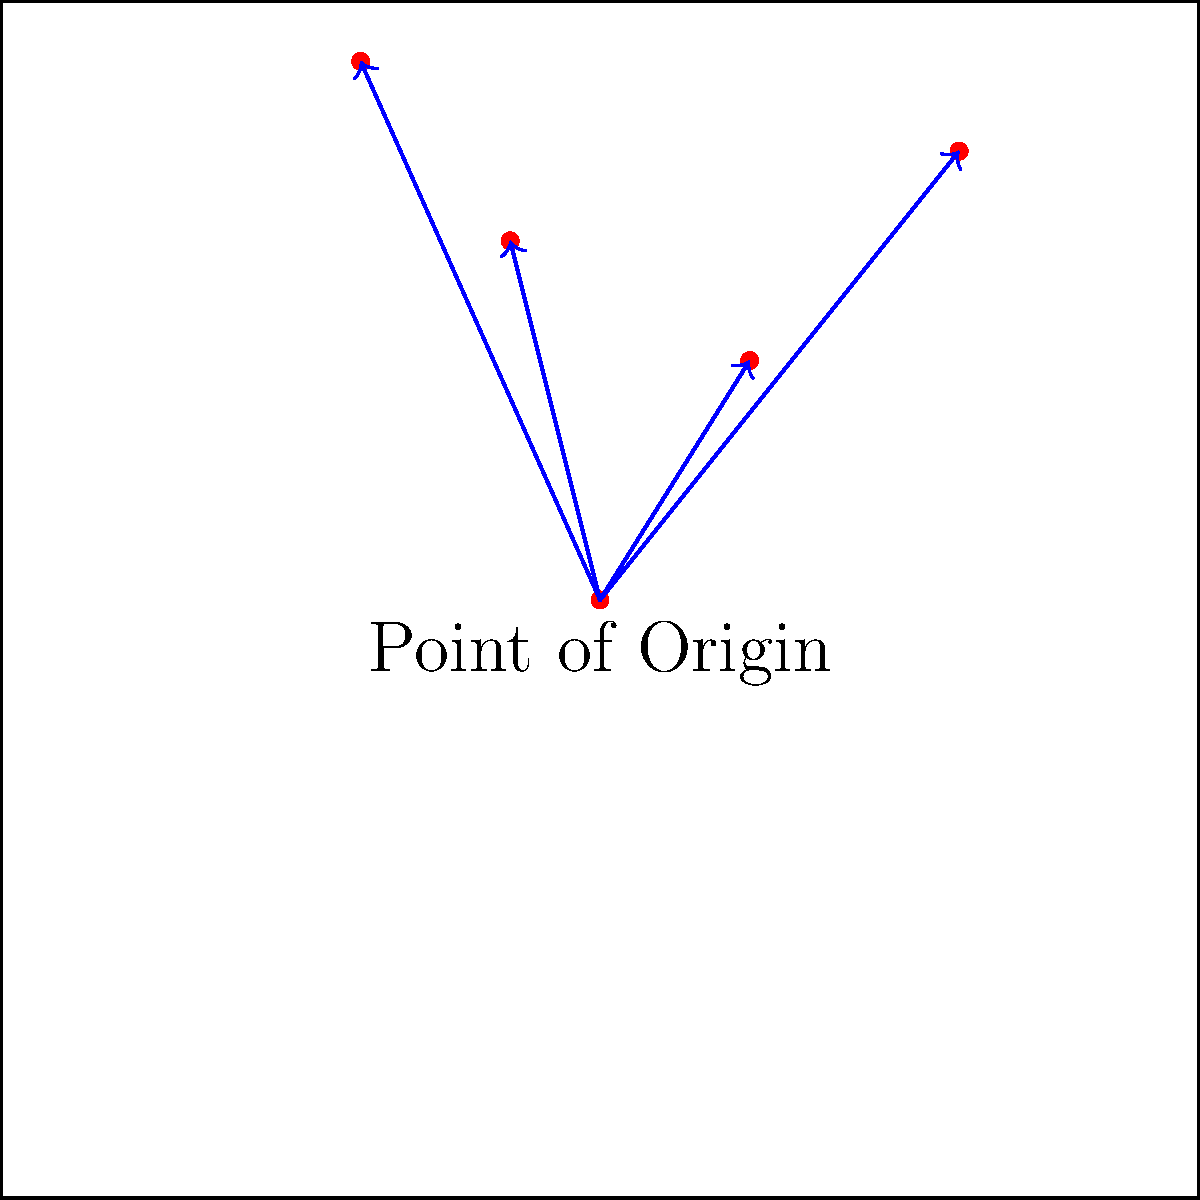Based on the blood spatter pattern and directional arrows shown in the graphic, what can be inferred about the point of origin of the blood source? How might this information be useful in a criminal defense case? 1. Observe the blood spatter pattern: The graphic shows multiple blood drops (red dots) on a surface.

2. Analyze the directional arrows: Blue arrows are drawn from a central point (labeled "Point of Origin") to each blood drop.

3. Interpret the arrow directions: All arrows are pointing upward and outward from the point of origin, suggesting a low-to-high trajectory.

4. Infer the point of origin: The convergence of arrows at the bottom center indicates this is likely the source of the blood.

5. Consider the implications:
   a) The blood source was likely at or near ground level.
   b) The spatter pattern suggests a forceful event, possibly an impact or arterial spray.

6. Relevance to criminal defense:
   a) Can help reconstruct the crime scene and victim's position.
   b) May corroborate or contradict witness testimonies.
   c) Could reveal inconsistencies in the prosecution's theory.
   d) Might suggest alternative scenarios that benefit the defense.

7. Use in courtroom demonstrations:
   a) Visual aid to explain blood spatter analysis to the jury.
   b) Can be used to challenge expert witnesses or propose alternative theories.
   c) Helps in creating convincing injury recreations for demonstrative purposes.
Answer: Low point of origin; useful for crime scene reconstruction and challenging prosecution's theory. 